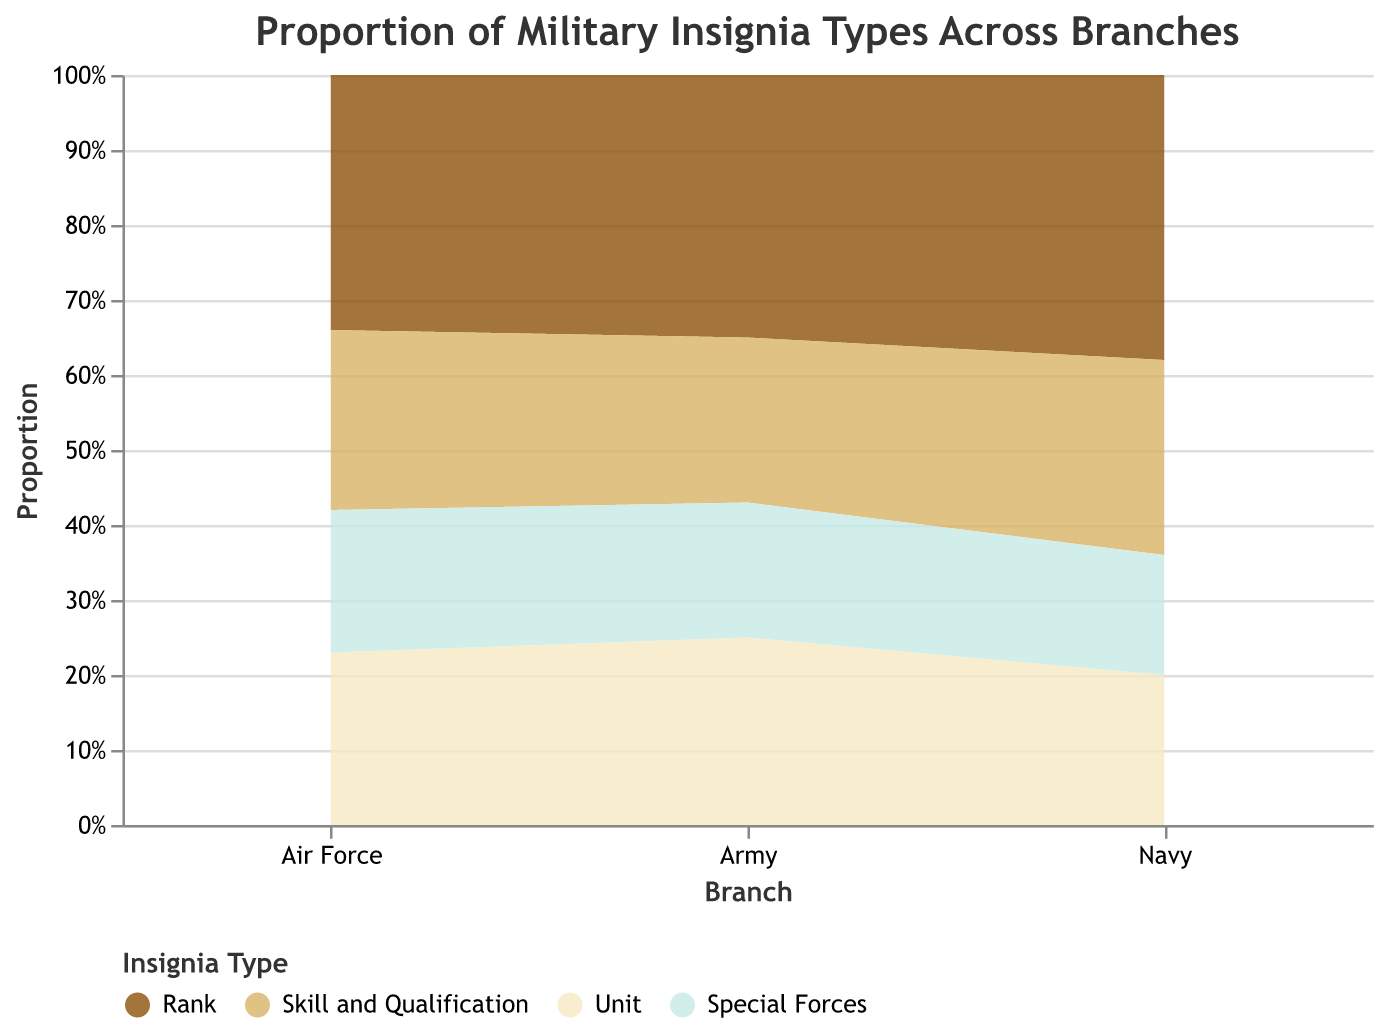What's the title of the figure? The title is usually found at the top of the figure. In this case, the title is "Proportion of Military Insignia Types Across Branches" as specified in the chart's code.
Answer: Proportion of Military Insignia Types Across Branches What branch has the highest proportion of the "Special Forces" insignia type? To answer this, look at the heights of the "Special Forces" section in each branch. The proportions are Army (0.18), Navy (0.16), and Air Force (0.19). Air Force has the highest proportion.
Answer: Air Force Among the three branches, which insignia type has the most consistent proportion across branches? This requires checking the variability of proportions of each insignia type across the branches. For "Rank," it's 0.35, 0.38, and 0.34. For "Skill and Qualification," it's 0.22, 0.26, and 0.24. For "Unit," it's 0.25, 0.20, and 0.23. For "Special Forces," it's 0.18, 0.16, and 0.19. "Rank" is the most consistent with proportions close to each other.
Answer: Rank Which branch has the lowest proportion of "Skill and Qualification" insignia type? Look at the proportions assigned to "Skill and Qualification" for each branch. They are Army (0.22), Navy (0.26), and Air Force (0.24). The Army has the lowest proportion.
Answer: Army What is the combined proportion of "Unit" and "Special Forces" insignia types in the Navy? Add the proportions of "Unit" (0.20) and "Special Forces" (0.16) for the Navy. 0.20 + 0.16 equals 0.36.
Answer: 0.36 How does the proportion of "Skill and Qualification" in the Navy compare to the proportion of "Skill and Qualification" in the Army? Compare the proportions: Navy (0.26) vs. Army (0.22). The proportion in the Navy is higher than in the Army.
Answer: Navy has a higher proportion What is the average proportion of the "Special Forces" insignia type across all branches? Sum the proportions for "Special Forces": 0.18 (Army) + 0.16 (Navy) + 0.19 (Air Force) = 0.53. Divide by the number of branches (3). 0.53 / 3 = 0.177.
Answer: 0.177 Does any branch have a higher proportion of "Special Forces" insignia type than "Unit" insignia type? Compare the "Special Forces" and "Unit" proportions within each branch. Army (0.18 < 0.25), Navy (0.16 < 0.20), Air Force (0.19 < 0.23). No branch has a higher "Special Forces" proportion than "Unit".
Answer: No Which insignia type dominates in the Air Force branch? The dominating insignia type will have the highest proportion in the Air Force. Examine the values for "Rank" (0.34), "Skill and Qualification" (0.24), "Unit" (0.23), and "Special Forces" (0.19). "Rank" has the highest proportion in the Air Force.
Answer: Rank 